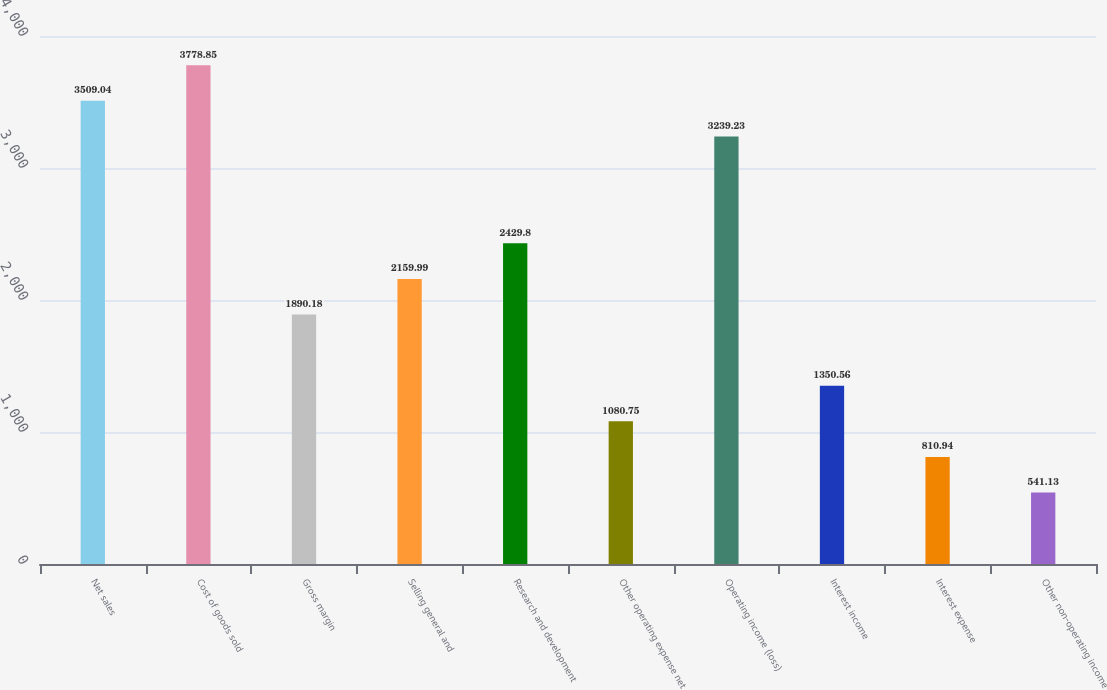Convert chart to OTSL. <chart><loc_0><loc_0><loc_500><loc_500><bar_chart><fcel>Net sales<fcel>Cost of goods sold<fcel>Gross margin<fcel>Selling general and<fcel>Research and development<fcel>Other operating expense net<fcel>Operating income (loss)<fcel>Interest income<fcel>Interest expense<fcel>Other non-operating income<nl><fcel>3509.04<fcel>3778.85<fcel>1890.18<fcel>2159.99<fcel>2429.8<fcel>1080.75<fcel>3239.23<fcel>1350.56<fcel>810.94<fcel>541.13<nl></chart> 